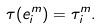Convert formula to latex. <formula><loc_0><loc_0><loc_500><loc_500>\tau ( e _ { i } ^ { m } ) = \tau _ { i } ^ { m } .</formula> 